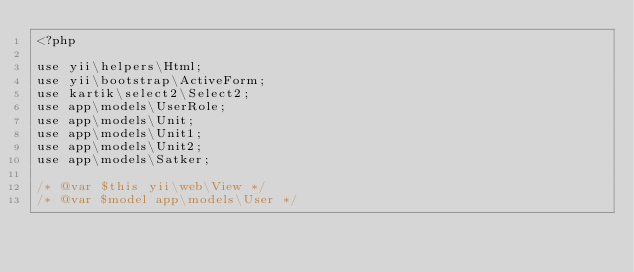Convert code to text. <code><loc_0><loc_0><loc_500><loc_500><_PHP_><?php

use yii\helpers\Html;
use yii\bootstrap\ActiveForm;
use kartik\select2\Select2;
use app\models\UserRole;
use app\models\Unit;
use app\models\Unit1;
use app\models\Unit2;
use app\models\Satker;

/* @var $this yii\web\View */
/* @var $model app\models\User */</code> 